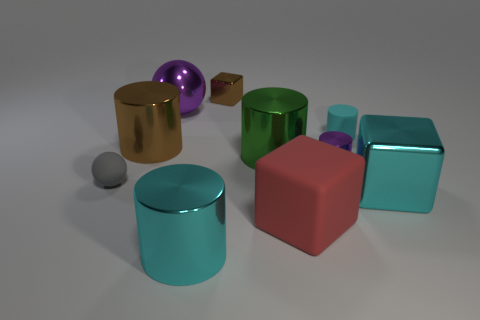Are there any other things that are the same shape as the big red matte thing?
Offer a terse response. Yes. What is the color of the small cylinder that is the same material as the big red object?
Offer a very short reply. Cyan. How many objects are tiny shiny blocks or big brown cylinders?
Offer a very short reply. 2. There is a gray thing; does it have the same size as the brown object that is behind the small cyan cylinder?
Provide a succinct answer. Yes. There is a tiny thing that is left of the metal cube left of the small rubber thing on the right side of the small gray rubber object; what is its color?
Keep it short and to the point. Gray. The big matte object is what color?
Provide a succinct answer. Red. Are there more tiny rubber things left of the small gray ball than shiny cubes that are on the right side of the big green metal cylinder?
Offer a very short reply. No. There is a tiny gray thing; is it the same shape as the cyan thing that is in front of the big cyan cube?
Make the answer very short. No. Is the size of the sphere behind the green metallic cylinder the same as the brown shiny object that is behind the rubber cylinder?
Your answer should be compact. No. There is a rubber object to the left of the block that is behind the large brown shiny cylinder; is there a red cube that is on the left side of it?
Make the answer very short. No. 